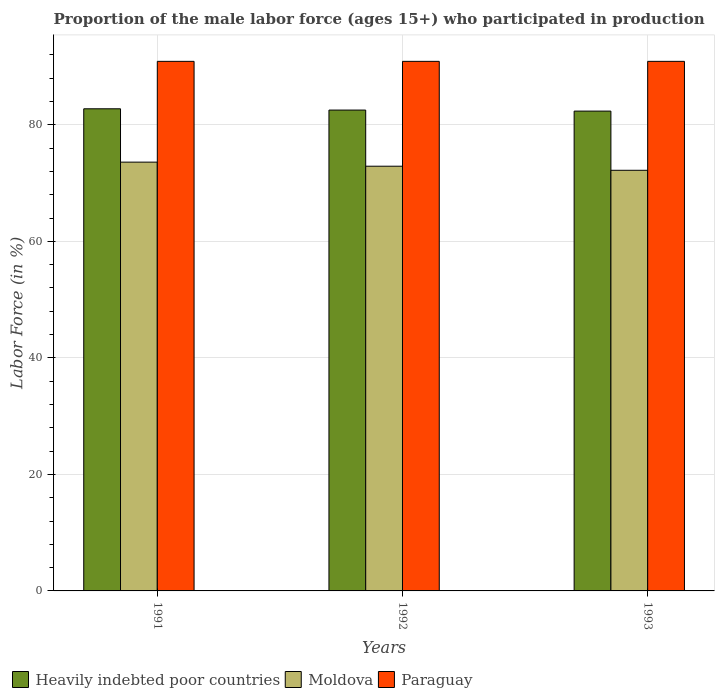How many different coloured bars are there?
Keep it short and to the point. 3. How many groups of bars are there?
Provide a succinct answer. 3. How many bars are there on the 2nd tick from the left?
Offer a terse response. 3. How many bars are there on the 1st tick from the right?
Keep it short and to the point. 3. In how many cases, is the number of bars for a given year not equal to the number of legend labels?
Make the answer very short. 0. What is the proportion of the male labor force who participated in production in Heavily indebted poor countries in 1993?
Your answer should be very brief. 82.36. Across all years, what is the maximum proportion of the male labor force who participated in production in Moldova?
Make the answer very short. 73.6. Across all years, what is the minimum proportion of the male labor force who participated in production in Moldova?
Your answer should be compact. 72.2. In which year was the proportion of the male labor force who participated in production in Paraguay maximum?
Provide a short and direct response. 1991. In which year was the proportion of the male labor force who participated in production in Heavily indebted poor countries minimum?
Provide a succinct answer. 1993. What is the total proportion of the male labor force who participated in production in Paraguay in the graph?
Provide a short and direct response. 272.7. What is the difference between the proportion of the male labor force who participated in production in Heavily indebted poor countries in 1993 and the proportion of the male labor force who participated in production in Paraguay in 1991?
Your answer should be compact. -8.54. What is the average proportion of the male labor force who participated in production in Paraguay per year?
Your answer should be compact. 90.9. In the year 1993, what is the difference between the proportion of the male labor force who participated in production in Heavily indebted poor countries and proportion of the male labor force who participated in production in Moldova?
Your response must be concise. 10.16. What is the ratio of the proportion of the male labor force who participated in production in Moldova in 1991 to that in 1993?
Your answer should be compact. 1.02. What is the difference between the highest and the second highest proportion of the male labor force who participated in production in Heavily indebted poor countries?
Give a very brief answer. 0.22. What is the difference between the highest and the lowest proportion of the male labor force who participated in production in Heavily indebted poor countries?
Keep it short and to the point. 0.4. In how many years, is the proportion of the male labor force who participated in production in Heavily indebted poor countries greater than the average proportion of the male labor force who participated in production in Heavily indebted poor countries taken over all years?
Keep it short and to the point. 1. What does the 2nd bar from the left in 1992 represents?
Provide a short and direct response. Moldova. What does the 2nd bar from the right in 1991 represents?
Your response must be concise. Moldova. Is it the case that in every year, the sum of the proportion of the male labor force who participated in production in Paraguay and proportion of the male labor force who participated in production in Moldova is greater than the proportion of the male labor force who participated in production in Heavily indebted poor countries?
Keep it short and to the point. Yes. How many bars are there?
Provide a short and direct response. 9. How many years are there in the graph?
Offer a terse response. 3. What is the difference between two consecutive major ticks on the Y-axis?
Keep it short and to the point. 20. Are the values on the major ticks of Y-axis written in scientific E-notation?
Ensure brevity in your answer.  No. Does the graph contain grids?
Your answer should be very brief. Yes. Where does the legend appear in the graph?
Provide a short and direct response. Bottom left. How are the legend labels stacked?
Provide a succinct answer. Horizontal. What is the title of the graph?
Your answer should be compact. Proportion of the male labor force (ages 15+) who participated in production. What is the label or title of the X-axis?
Offer a very short reply. Years. What is the Labor Force (in %) in Heavily indebted poor countries in 1991?
Your response must be concise. 82.76. What is the Labor Force (in %) in Moldova in 1991?
Make the answer very short. 73.6. What is the Labor Force (in %) in Paraguay in 1991?
Make the answer very short. 90.9. What is the Labor Force (in %) in Heavily indebted poor countries in 1992?
Ensure brevity in your answer.  82.54. What is the Labor Force (in %) in Moldova in 1992?
Offer a very short reply. 72.9. What is the Labor Force (in %) of Paraguay in 1992?
Provide a short and direct response. 90.9. What is the Labor Force (in %) of Heavily indebted poor countries in 1993?
Ensure brevity in your answer.  82.36. What is the Labor Force (in %) of Moldova in 1993?
Ensure brevity in your answer.  72.2. What is the Labor Force (in %) of Paraguay in 1993?
Ensure brevity in your answer.  90.9. Across all years, what is the maximum Labor Force (in %) of Heavily indebted poor countries?
Keep it short and to the point. 82.76. Across all years, what is the maximum Labor Force (in %) of Moldova?
Your answer should be compact. 73.6. Across all years, what is the maximum Labor Force (in %) in Paraguay?
Ensure brevity in your answer.  90.9. Across all years, what is the minimum Labor Force (in %) of Heavily indebted poor countries?
Offer a very short reply. 82.36. Across all years, what is the minimum Labor Force (in %) of Moldova?
Your answer should be very brief. 72.2. Across all years, what is the minimum Labor Force (in %) in Paraguay?
Ensure brevity in your answer.  90.9. What is the total Labor Force (in %) of Heavily indebted poor countries in the graph?
Offer a terse response. 247.66. What is the total Labor Force (in %) of Moldova in the graph?
Ensure brevity in your answer.  218.7. What is the total Labor Force (in %) of Paraguay in the graph?
Give a very brief answer. 272.7. What is the difference between the Labor Force (in %) in Heavily indebted poor countries in 1991 and that in 1992?
Provide a short and direct response. 0.22. What is the difference between the Labor Force (in %) of Heavily indebted poor countries in 1991 and that in 1993?
Give a very brief answer. 0.4. What is the difference between the Labor Force (in %) of Moldova in 1991 and that in 1993?
Offer a terse response. 1.4. What is the difference between the Labor Force (in %) of Heavily indebted poor countries in 1992 and that in 1993?
Your answer should be very brief. 0.18. What is the difference between the Labor Force (in %) in Heavily indebted poor countries in 1991 and the Labor Force (in %) in Moldova in 1992?
Your answer should be very brief. 9.86. What is the difference between the Labor Force (in %) in Heavily indebted poor countries in 1991 and the Labor Force (in %) in Paraguay in 1992?
Ensure brevity in your answer.  -8.14. What is the difference between the Labor Force (in %) in Moldova in 1991 and the Labor Force (in %) in Paraguay in 1992?
Your response must be concise. -17.3. What is the difference between the Labor Force (in %) of Heavily indebted poor countries in 1991 and the Labor Force (in %) of Moldova in 1993?
Your response must be concise. 10.56. What is the difference between the Labor Force (in %) of Heavily indebted poor countries in 1991 and the Labor Force (in %) of Paraguay in 1993?
Your answer should be compact. -8.14. What is the difference between the Labor Force (in %) of Moldova in 1991 and the Labor Force (in %) of Paraguay in 1993?
Provide a short and direct response. -17.3. What is the difference between the Labor Force (in %) of Heavily indebted poor countries in 1992 and the Labor Force (in %) of Moldova in 1993?
Offer a very short reply. 10.34. What is the difference between the Labor Force (in %) of Heavily indebted poor countries in 1992 and the Labor Force (in %) of Paraguay in 1993?
Provide a short and direct response. -8.36. What is the average Labor Force (in %) in Heavily indebted poor countries per year?
Your answer should be very brief. 82.55. What is the average Labor Force (in %) of Moldova per year?
Ensure brevity in your answer.  72.9. What is the average Labor Force (in %) in Paraguay per year?
Your answer should be compact. 90.9. In the year 1991, what is the difference between the Labor Force (in %) in Heavily indebted poor countries and Labor Force (in %) in Moldova?
Give a very brief answer. 9.16. In the year 1991, what is the difference between the Labor Force (in %) of Heavily indebted poor countries and Labor Force (in %) of Paraguay?
Offer a terse response. -8.14. In the year 1991, what is the difference between the Labor Force (in %) in Moldova and Labor Force (in %) in Paraguay?
Offer a terse response. -17.3. In the year 1992, what is the difference between the Labor Force (in %) of Heavily indebted poor countries and Labor Force (in %) of Moldova?
Your response must be concise. 9.64. In the year 1992, what is the difference between the Labor Force (in %) of Heavily indebted poor countries and Labor Force (in %) of Paraguay?
Ensure brevity in your answer.  -8.36. In the year 1993, what is the difference between the Labor Force (in %) of Heavily indebted poor countries and Labor Force (in %) of Moldova?
Your answer should be very brief. 10.16. In the year 1993, what is the difference between the Labor Force (in %) of Heavily indebted poor countries and Labor Force (in %) of Paraguay?
Offer a terse response. -8.54. In the year 1993, what is the difference between the Labor Force (in %) in Moldova and Labor Force (in %) in Paraguay?
Your answer should be compact. -18.7. What is the ratio of the Labor Force (in %) in Moldova in 1991 to that in 1992?
Provide a succinct answer. 1.01. What is the ratio of the Labor Force (in %) of Paraguay in 1991 to that in 1992?
Give a very brief answer. 1. What is the ratio of the Labor Force (in %) in Moldova in 1991 to that in 1993?
Your answer should be compact. 1.02. What is the ratio of the Labor Force (in %) of Heavily indebted poor countries in 1992 to that in 1993?
Your answer should be very brief. 1. What is the ratio of the Labor Force (in %) of Moldova in 1992 to that in 1993?
Provide a short and direct response. 1.01. What is the ratio of the Labor Force (in %) in Paraguay in 1992 to that in 1993?
Your answer should be compact. 1. What is the difference between the highest and the second highest Labor Force (in %) in Heavily indebted poor countries?
Your answer should be very brief. 0.22. What is the difference between the highest and the lowest Labor Force (in %) of Heavily indebted poor countries?
Ensure brevity in your answer.  0.4. 